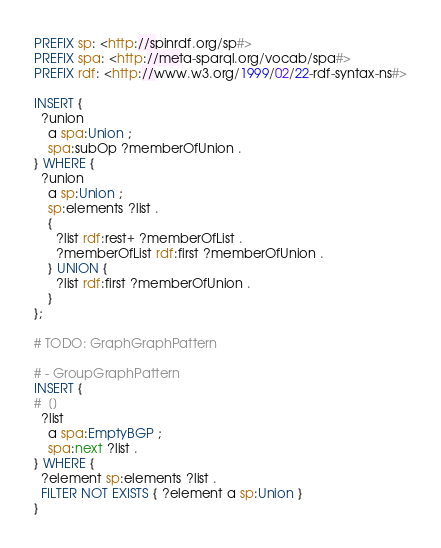Convert code to text. <code><loc_0><loc_0><loc_500><loc_500><_Ruby_>PREFIX sp: <http://spinrdf.org/sp#>
PREFIX spa: <http://meta-sparql.org/vocab/spa#>
PREFIX rdf: <http://www.w3.org/1999/02/22-rdf-syntax-ns#>

INSERT {
  ?union
    a spa:Union ;
    spa:subOp ?memberOfUnion .
} WHERE {
  ?union
    a sp:Union ;
    sp:elements ?list .
    {
      ?list rdf:rest+ ?memberOfList .
      ?memberOfList rdf:first ?memberOfUnion .
    } UNION {
      ?list rdf:first ?memberOfUnion .
    }
};

# TODO: GraphGraphPattern

# - GroupGraphPattern
INSERT {
#  []
  ?list
    a spa:EmptyBGP ;
    spa:next ?list .
} WHERE {
  ?element sp:elements ?list .
  FILTER NOT EXISTS { ?element a sp:Union }
}
</code> 